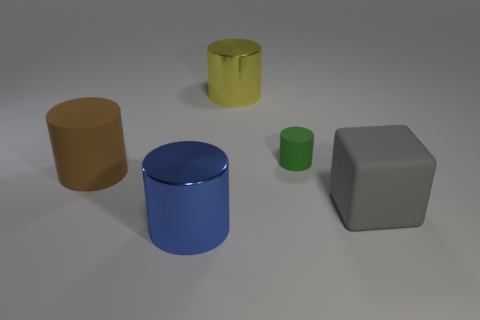How many balls are big things or big cyan metal objects?
Provide a short and direct response. 0. How many things are both in front of the large matte cylinder and behind the big blue thing?
Give a very brief answer. 1. Are there the same number of metallic things that are on the left side of the blue metallic object and tiny green matte cylinders behind the green thing?
Keep it short and to the point. Yes. There is a big metal object behind the green rubber thing; does it have the same shape as the large gray rubber object?
Provide a succinct answer. No. There is a metal thing that is in front of the matte cylinder that is left of the small green rubber thing right of the large blue metal cylinder; what is its shape?
Your answer should be compact. Cylinder. There is a big cylinder that is both right of the large brown rubber object and in front of the green object; what material is it made of?
Ensure brevity in your answer.  Metal. Is the number of metallic cylinders less than the number of large green cylinders?
Your response must be concise. No. Do the yellow metallic thing and the shiny object to the left of the yellow object have the same shape?
Offer a terse response. Yes. There is a cylinder that is right of the yellow shiny thing; is it the same size as the large rubber cube?
Provide a succinct answer. No. The brown rubber thing that is the same size as the blue metallic thing is what shape?
Offer a terse response. Cylinder. 